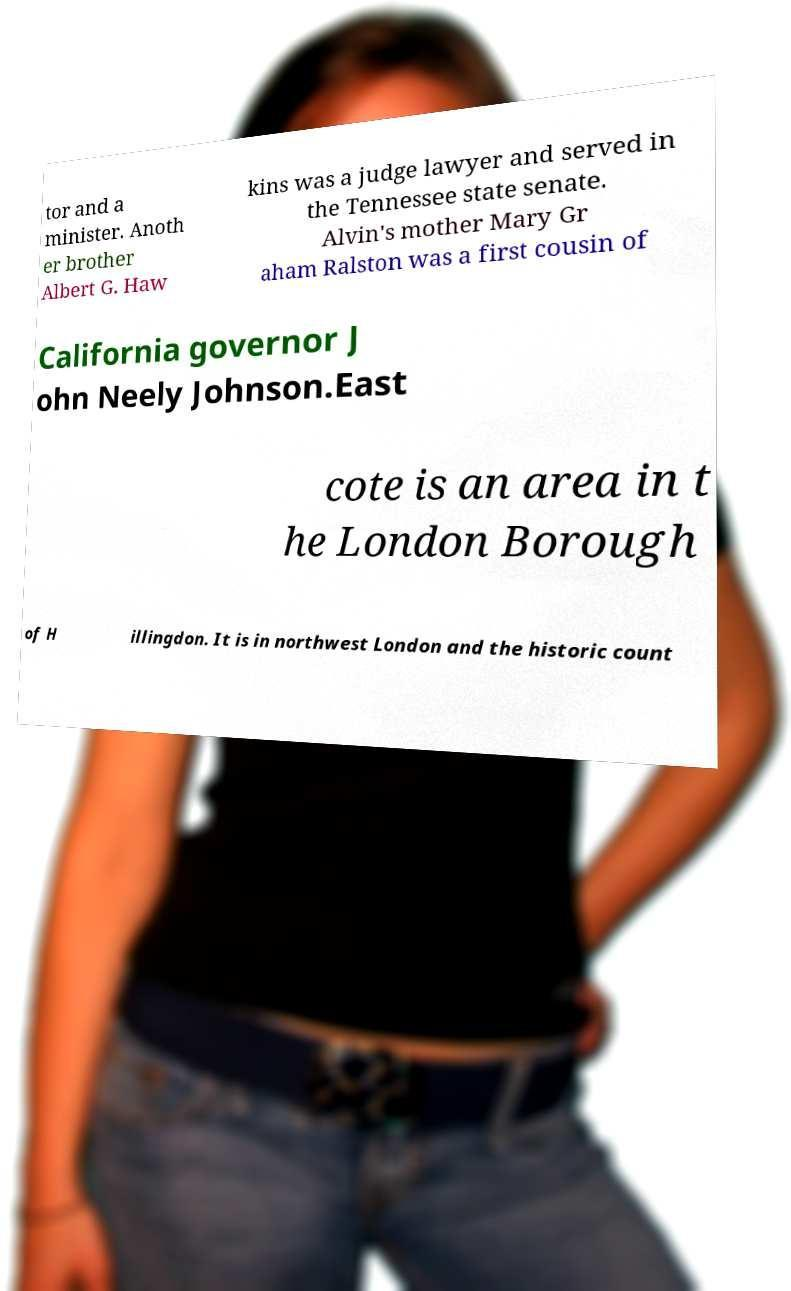Can you read and provide the text displayed in the image?This photo seems to have some interesting text. Can you extract and type it out for me? tor and a minister. Anoth er brother Albert G. Haw kins was a judge lawyer and served in the Tennessee state senate. Alvin's mother Mary Gr aham Ralston was a first cousin of California governor J ohn Neely Johnson.East cote is an area in t he London Borough of H illingdon. It is in northwest London and the historic count 